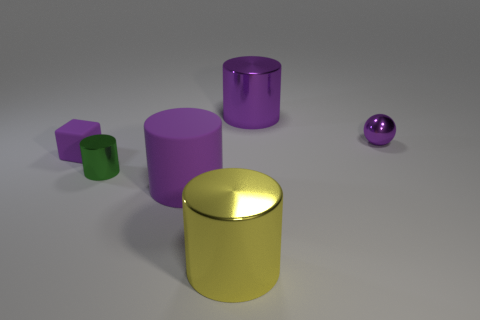Do the green cylinder and the small purple block have the same material?
Provide a succinct answer. No. What material is the cylinder behind the small metal object to the left of the big purple thing left of the big yellow shiny cylinder made of?
Offer a terse response. Metal. Do the cylinder on the right side of the big yellow shiny thing and the big purple thing that is in front of the small purple shiny ball have the same material?
Your answer should be compact. No. What material is the purple sphere that is the same size as the purple block?
Provide a succinct answer. Metal. There is a large metal object that is to the left of the big shiny cylinder that is behind the block; what number of purple balls are in front of it?
Your response must be concise. 0. Is the color of the object that is behind the purple metal sphere the same as the matte thing left of the green object?
Ensure brevity in your answer.  Yes. There is a tiny object that is both on the right side of the small purple matte object and behind the tiny green metallic thing; what color is it?
Provide a short and direct response. Purple. How many purple balls are the same size as the green metal cylinder?
Keep it short and to the point. 1. There is a large metallic thing behind the tiny purple object that is in front of the small purple shiny sphere; what is its shape?
Your answer should be very brief. Cylinder. There is a yellow shiny object that is on the left side of the shiny object to the right of the big metallic object behind the small green cylinder; what shape is it?
Give a very brief answer. Cylinder. 